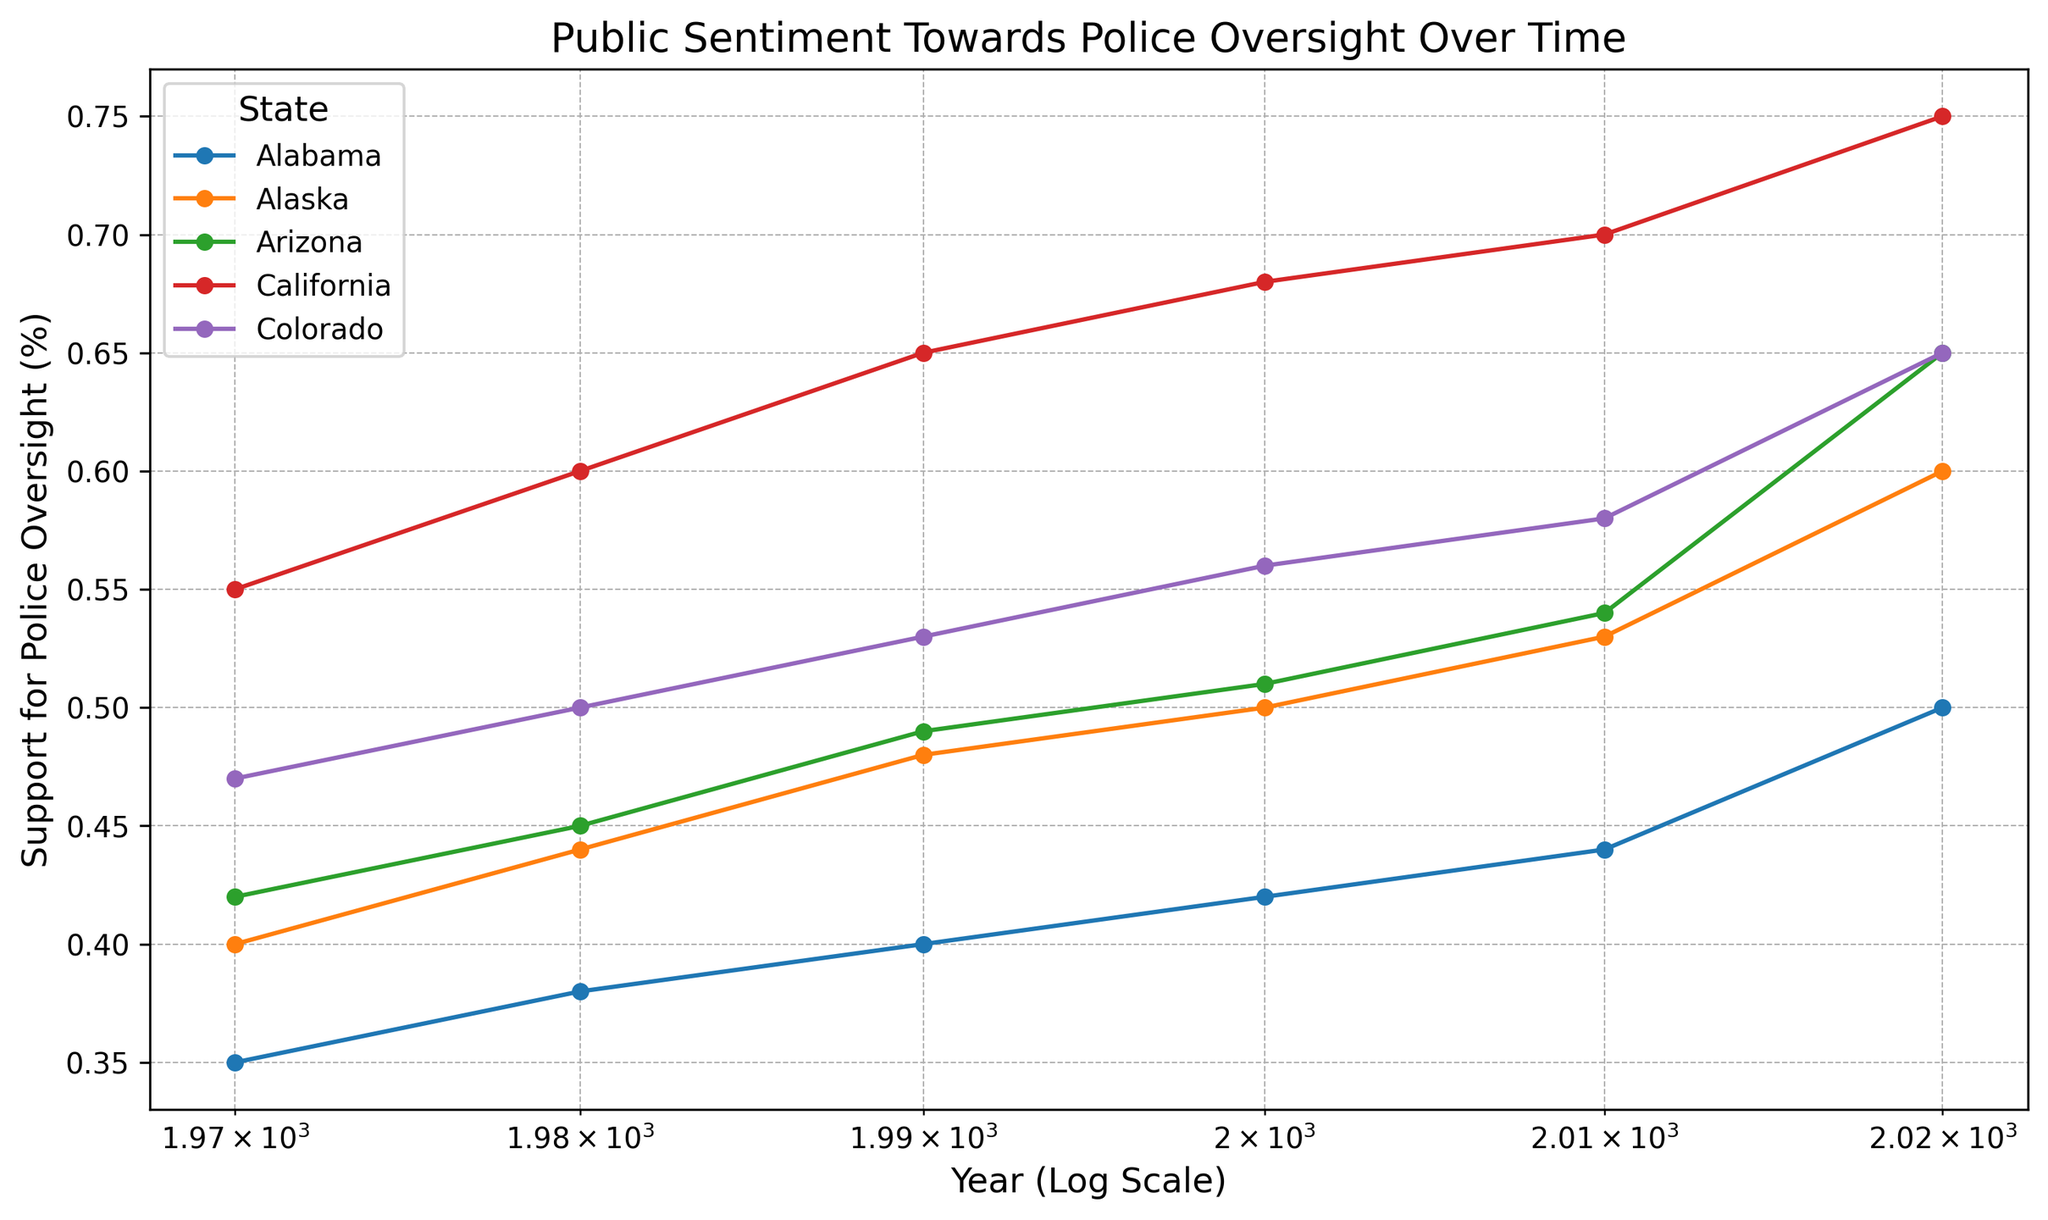Which state had the highest support for police oversight in 2020? By examining the different colored lines on the graph in the year 2020, the highest point indicates the state with the greatest support. The line for California reaches the highest point on the y-axis in 2020.
Answer: California Has support for police oversight in Alabama increased, decreased, or remained the same between 1970 and 2020? By observing the line corresponding to Alabama and comparing its y-axis positions in 1970 versus 2020, it's clear that the support percentage has increased from 0.35 in 1970 to 0.50 in 2020.
Answer: Increased Which state had the smallest increase in support for police oversight from 1970 to 2020? To answer this, compare the vertical differences (y-axis) for each state from 1970 to 2020. Alabama shows an increase from 0.35 to 0.50, an increase of 0.15, while other states have larger differences.
Answer: Alabama Between which two consecutive decades did California see the most significant increase in support for police oversight? By examining the line for California and the steepness of the slope between each decade marker, the largest increase is from 1990 (0.65) to 2000 (0.68).
Answer: 1990 to 2000 What is the average support for police oversight in Colorado from 1970 to 2020? The values for Colorado across the years are 0.47, 0.50, 0.53, 0.56, 0.58, and 0.65. Adding these gives 3.29, and dividing by the number of data points (6) provides the average: 3.29 / 6 ≈ 0.548.
Answer: 0.548 How did public opinion in Arizona change between 1980 and 2000? Comparing the y-axis values for Arizona in 1980 (0.45) and 2000 (0.51), there is an increase of 0.06.
Answer: Increased Which state had the second-highest support for police oversight in 1980? Observing the y-axis values for all states in 1980 and identifying the second largest value, Alaska (0.44) is second after California (0.60).
Answer: Alaska Did any states show a decrease in support for police oversight between any two decades? By individually examining each state line, all lines display an upward trend over time without any dips, indicating no decreases through the decades.
Answer: No During which decade did Alaska see the steepest increase in support for police oversight? Observing the slope of the line for Alaska between each decade, the steepest increase is seen between 2010 (0.53) and 2020 (0.60).
Answer: 2010 to 2020 What's the difference in support for police oversight between California and Arizona in 2020? The vertical difference (y-axis value) for California in 2020 is 0.75 and for Arizona it is 0.65. Subtracting these gives 0.75 - 0.65 = 0.10.
Answer: 0.10 